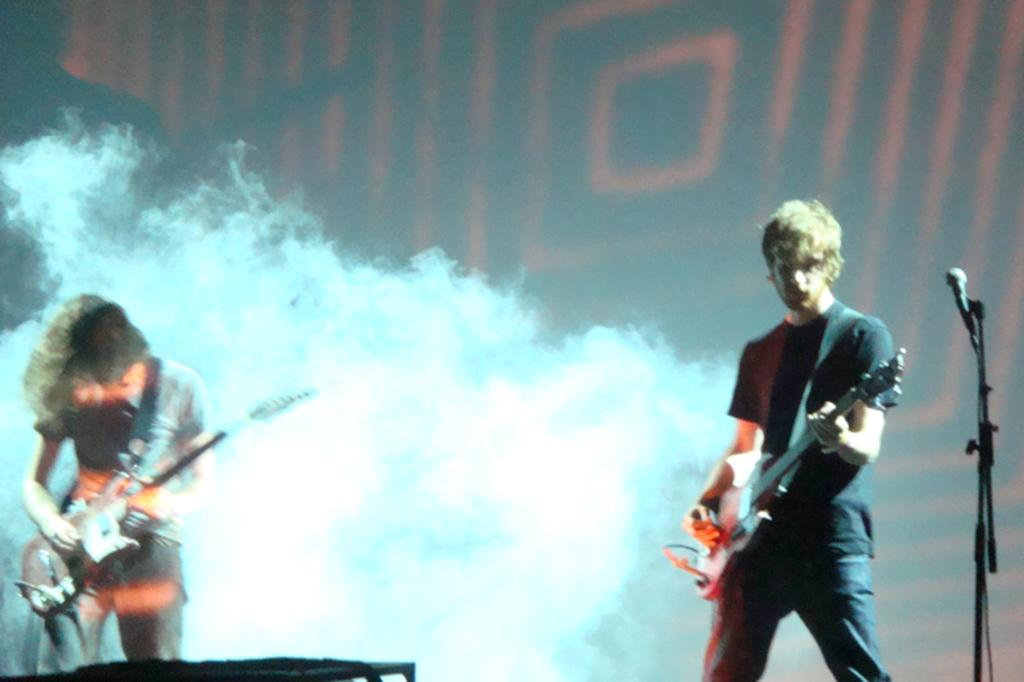How many people are in the image? There are two persons in the image. What are the two persons doing in the image? The two persons are playing the guitar. Can you describe any other objects in the image besides the people? Yes, there is a microphone stand on the right side of the image. Where is the snail located in the image? There is no snail present in the image. What type of crib can be seen in the image? There is no crib present in the image. 